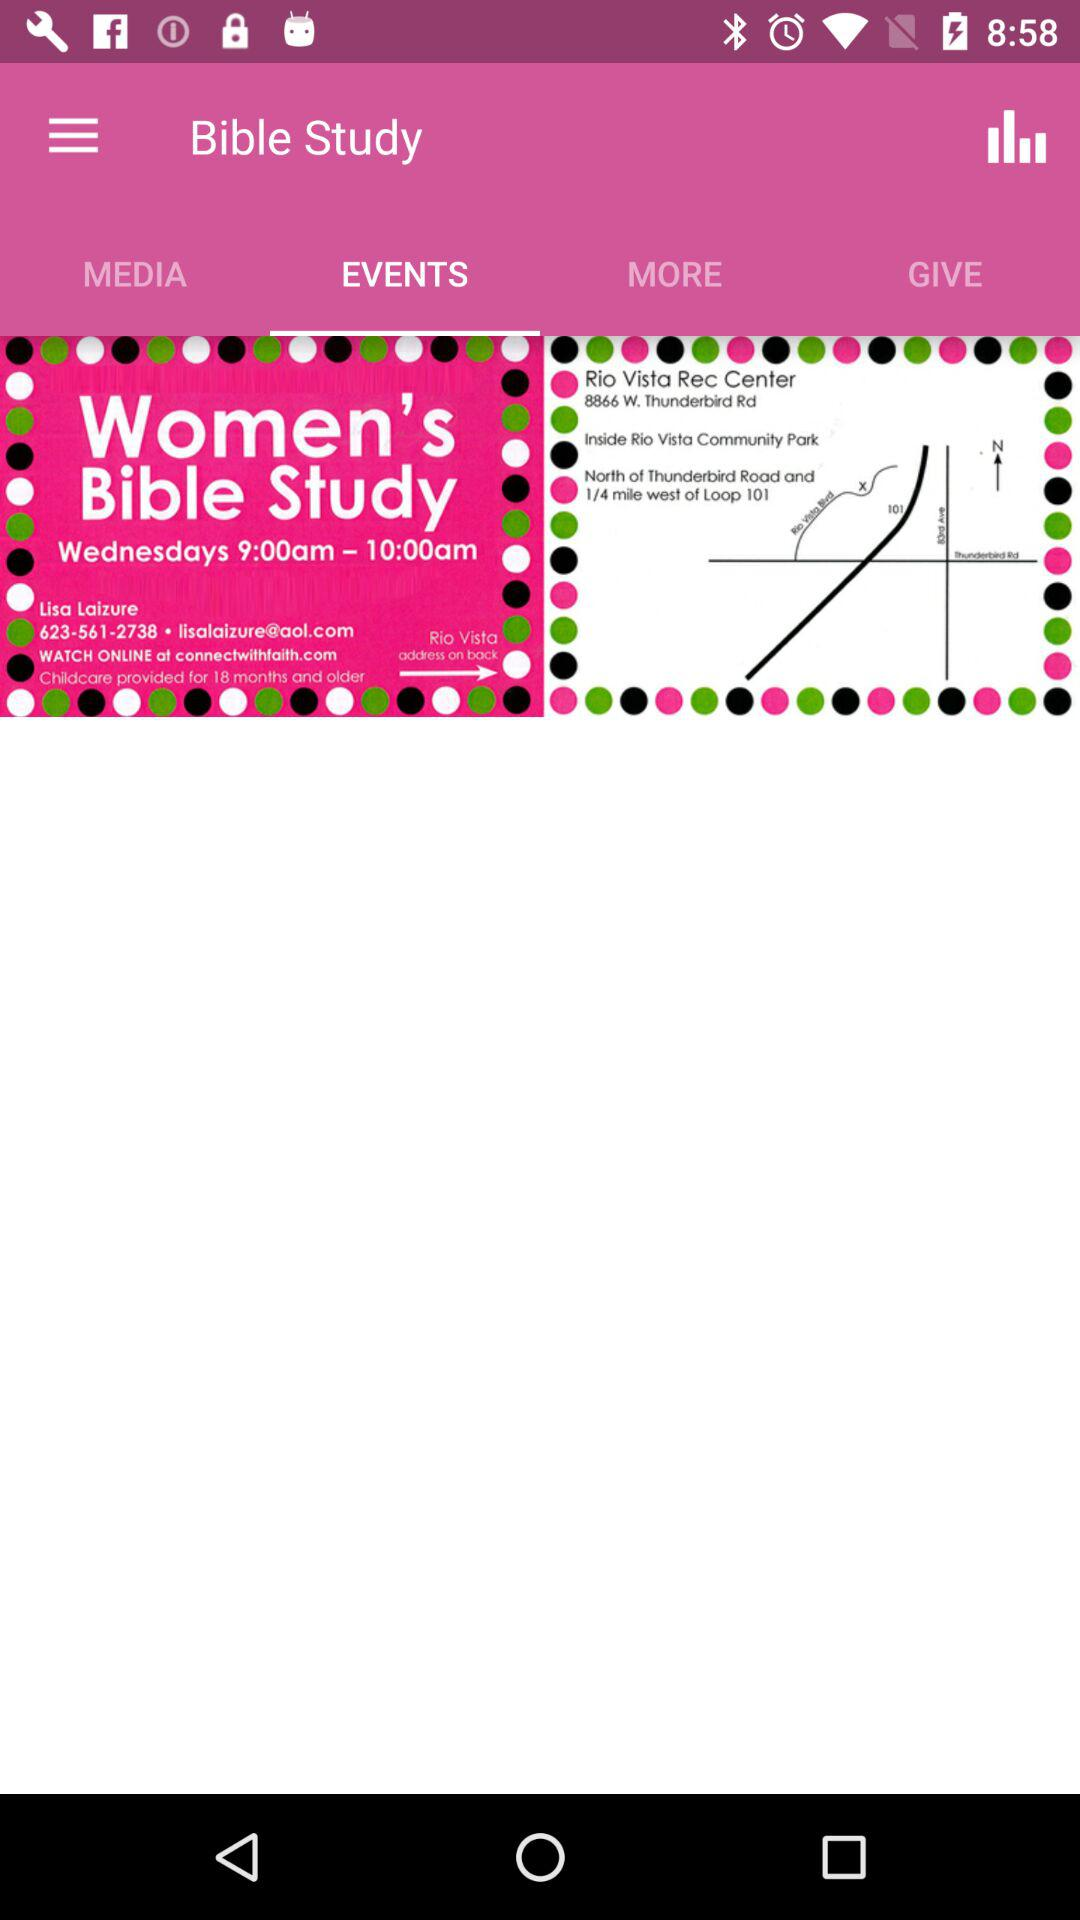What is the contact number? The contact number is 623-561-2738. 